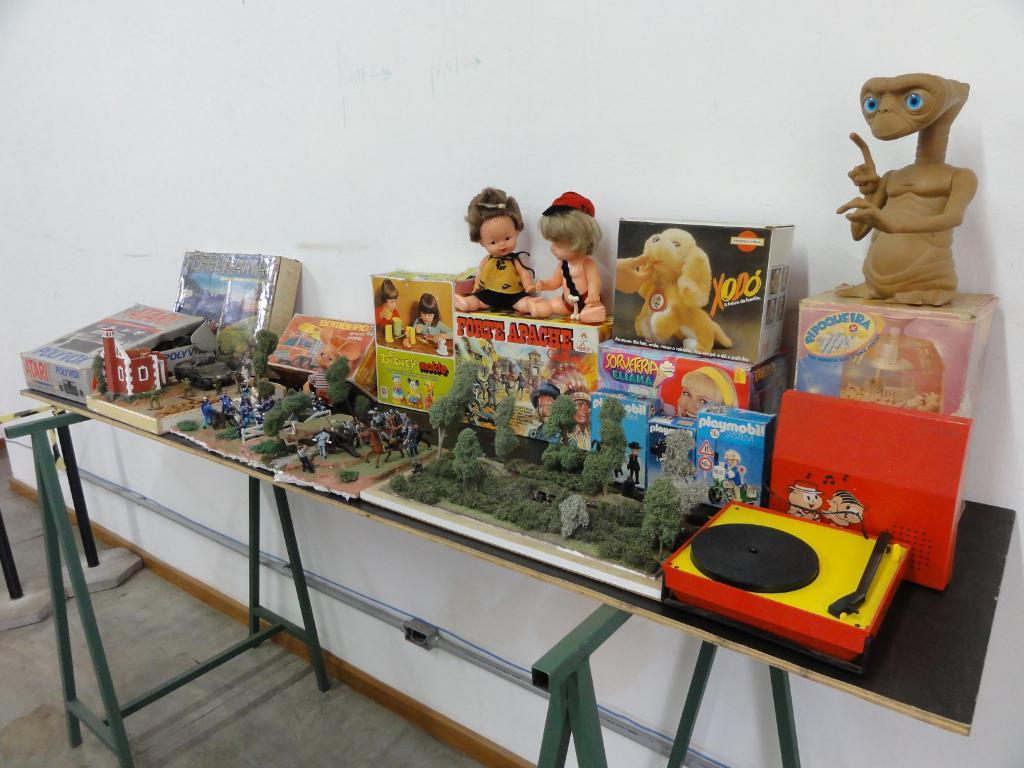Provide a one-sentence caption for the provided image. A table full of toys one of which is a puppy called XODO. 